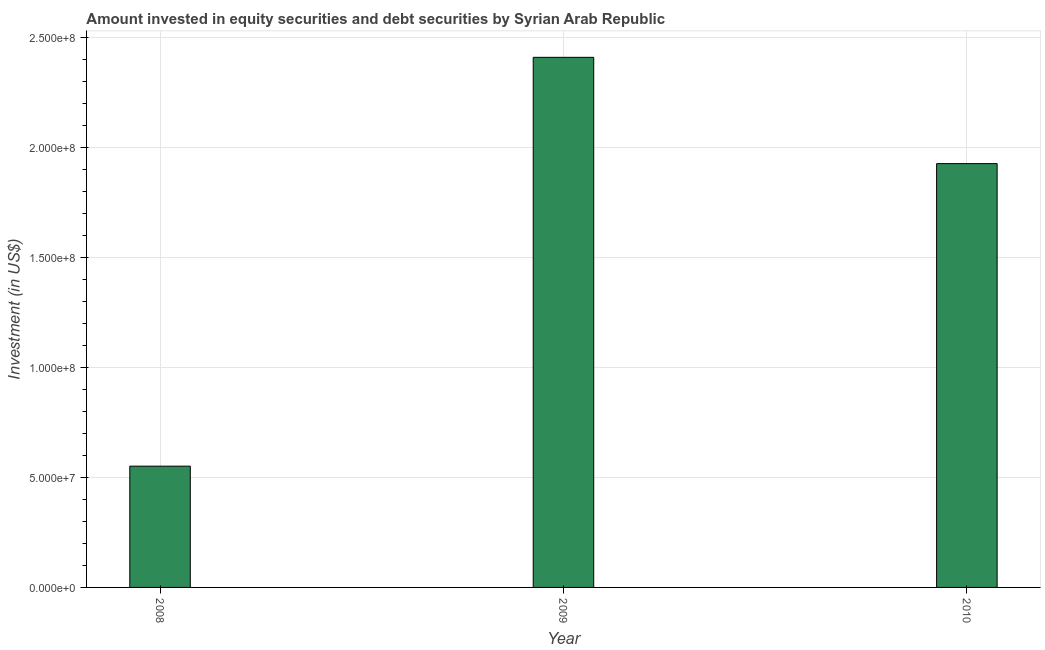Does the graph contain grids?
Offer a terse response. Yes. What is the title of the graph?
Provide a succinct answer. Amount invested in equity securities and debt securities by Syrian Arab Republic. What is the label or title of the Y-axis?
Your answer should be compact. Investment (in US$). What is the portfolio investment in 2008?
Ensure brevity in your answer.  5.51e+07. Across all years, what is the maximum portfolio investment?
Keep it short and to the point. 2.41e+08. Across all years, what is the minimum portfolio investment?
Keep it short and to the point. 5.51e+07. In which year was the portfolio investment maximum?
Your response must be concise. 2009. What is the sum of the portfolio investment?
Keep it short and to the point. 4.89e+08. What is the difference between the portfolio investment in 2008 and 2009?
Ensure brevity in your answer.  -1.86e+08. What is the average portfolio investment per year?
Your answer should be compact. 1.63e+08. What is the median portfolio investment?
Keep it short and to the point. 1.93e+08. What is the ratio of the portfolio investment in 2008 to that in 2010?
Provide a succinct answer. 0.29. Is the portfolio investment in 2008 less than that in 2010?
Offer a terse response. Yes. What is the difference between the highest and the second highest portfolio investment?
Make the answer very short. 4.83e+07. Is the sum of the portfolio investment in 2009 and 2010 greater than the maximum portfolio investment across all years?
Provide a short and direct response. Yes. What is the difference between the highest and the lowest portfolio investment?
Offer a terse response. 1.86e+08. In how many years, is the portfolio investment greater than the average portfolio investment taken over all years?
Offer a terse response. 2. How many bars are there?
Your answer should be compact. 3. How many years are there in the graph?
Your answer should be very brief. 3. Are the values on the major ticks of Y-axis written in scientific E-notation?
Make the answer very short. Yes. What is the Investment (in US$) in 2008?
Provide a succinct answer. 5.51e+07. What is the Investment (in US$) of 2009?
Your answer should be compact. 2.41e+08. What is the Investment (in US$) in 2010?
Give a very brief answer. 1.93e+08. What is the difference between the Investment (in US$) in 2008 and 2009?
Your answer should be very brief. -1.86e+08. What is the difference between the Investment (in US$) in 2008 and 2010?
Give a very brief answer. -1.38e+08. What is the difference between the Investment (in US$) in 2009 and 2010?
Your response must be concise. 4.83e+07. What is the ratio of the Investment (in US$) in 2008 to that in 2009?
Offer a very short reply. 0.23. What is the ratio of the Investment (in US$) in 2008 to that in 2010?
Your answer should be compact. 0.29. What is the ratio of the Investment (in US$) in 2009 to that in 2010?
Make the answer very short. 1.25. 